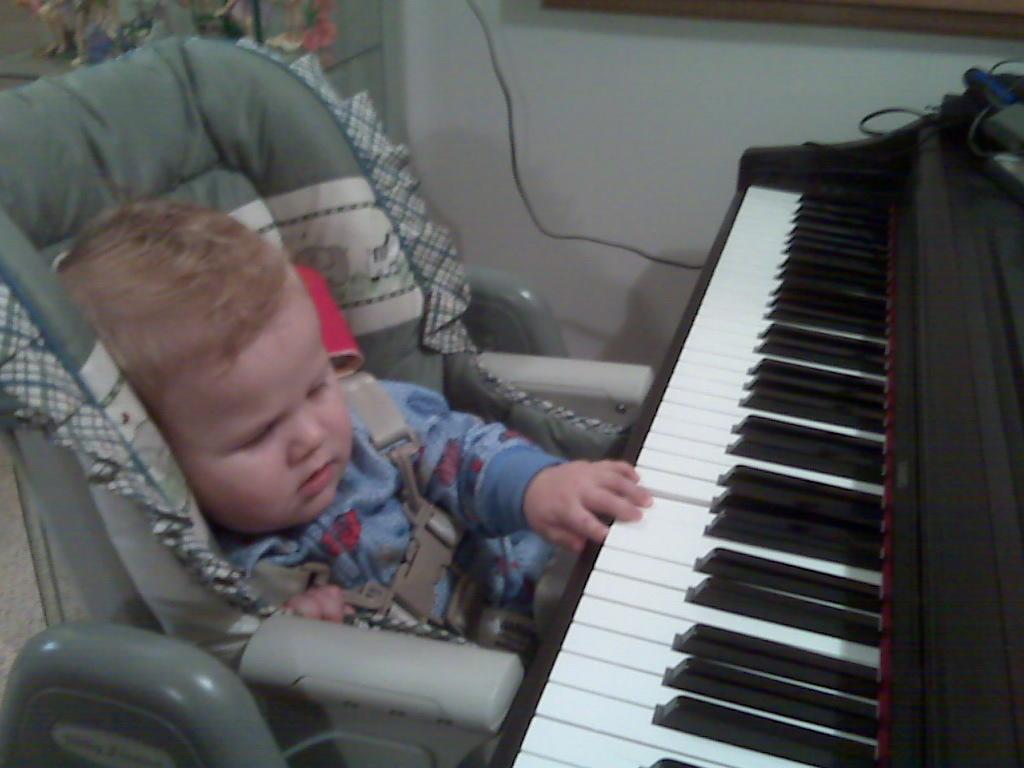In one or two sentences, can you explain what this image depicts? In this picture there is a boy who is sitting on the chair. He is holding a piano. There is a wire and some show pieces in the shelf. 